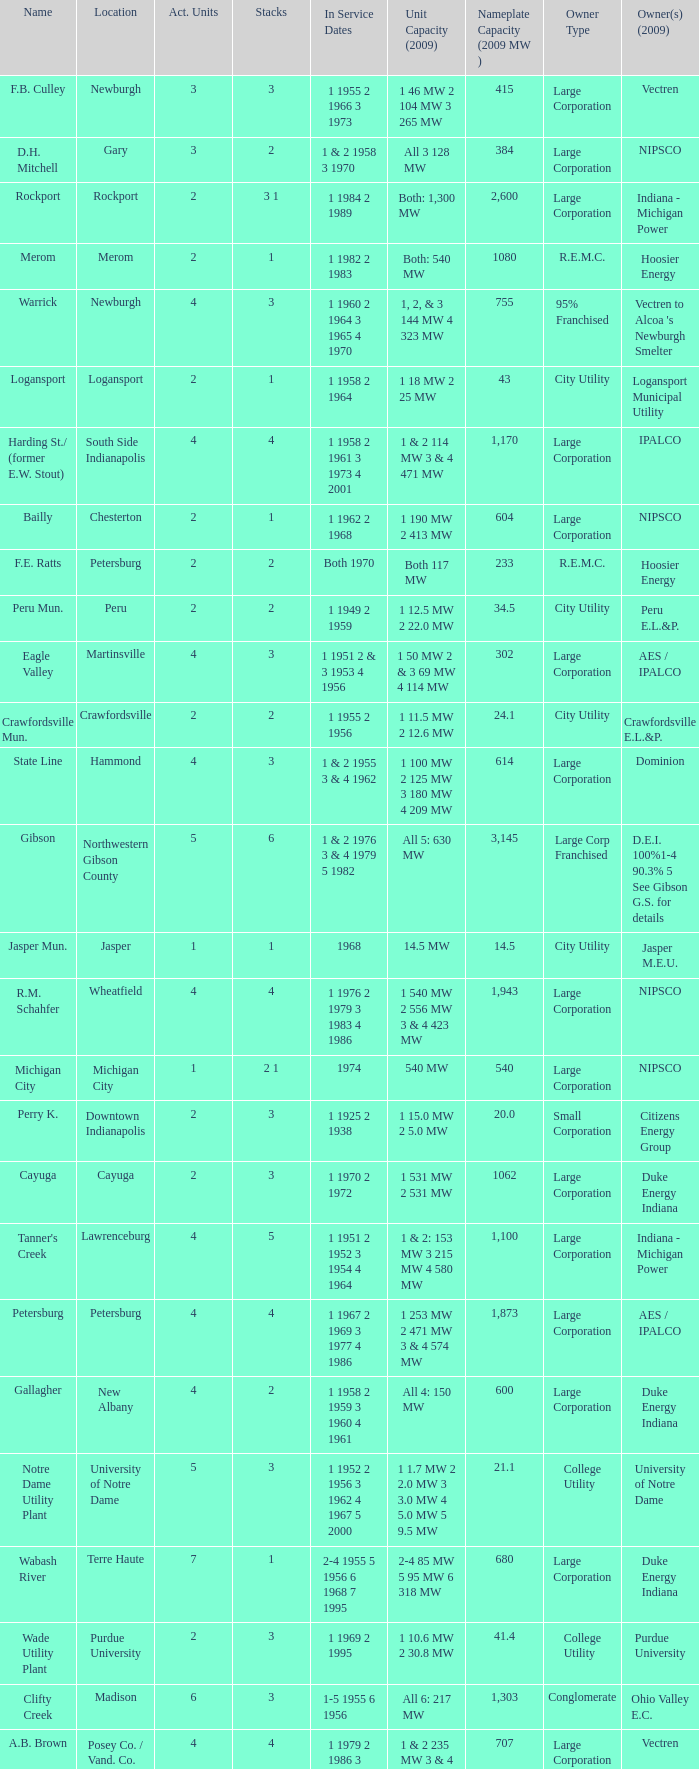Name the stacks for 1 1969 2 1995 3.0. 